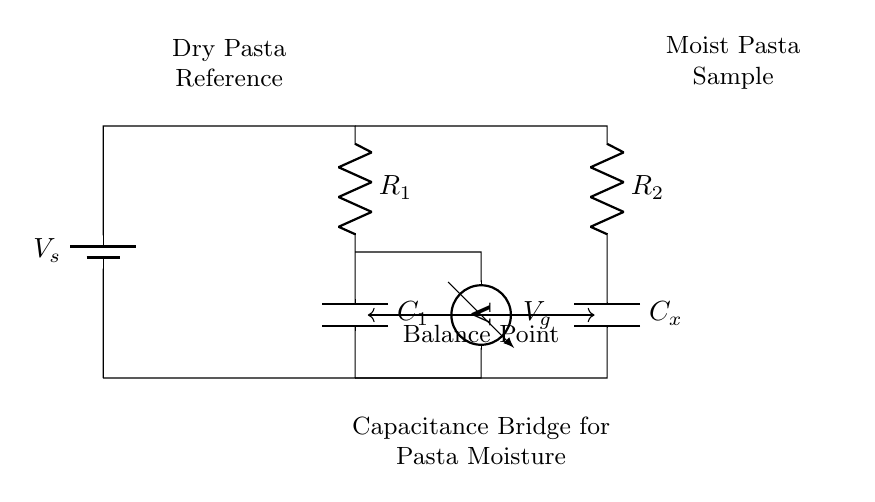What type of bridge circuit is represented here? This circuit is a capacitance bridge, which is designed to compare the capacitance of a reference capacitor with that of an unknown capacitor. The arrangement with two branches and a voltmeter shows it is structured for measuring capacitance.
Answer: Capacitance bridge What does the voltmeter measure in this circuit? The voltmeter measures the potential difference at the balance point between the two branches of the circuit. This voltage indicates whether the capacitance in the sample branch matches that of the reference branch.
Answer: Voltage How many capacitors are included in the circuit? There are two capacitors shown in the diagram: one is the reference capacitor (C1), and the other is the unknown capacitor (Cx). These capacitors are essential for measuring moisture levels in pasta dough by analyzing capacitance changes.
Answer: Two What is the role of R2 in this bridge circuit? Resistor R2, situated in the sample branch with the unknown capacitor, helps establish a balance in the bridge circuit by being in series with Cx. It influences the voltage measured by the voltmeter and aids in the calibration of the moisture measurement.
Answer: Balance What is indicated by the balance point in this circuit? The balance point, where the voltmeter reads zero volts, signifies that the two capacitors (C1 and Cx) have equal reactance at the frequency of the applied voltage. This condition occurs when the moisture content in the sample matches that of the reference.
Answer: Moisture equality What does the battery provide in this circuit? The battery provides the necessary voltage supply (Vs) for the bridge circuit, allowing current to flow through the components and facilitating the measurement process. The voltage is needed for the operation of the circuit.
Answer: Voltage supply 